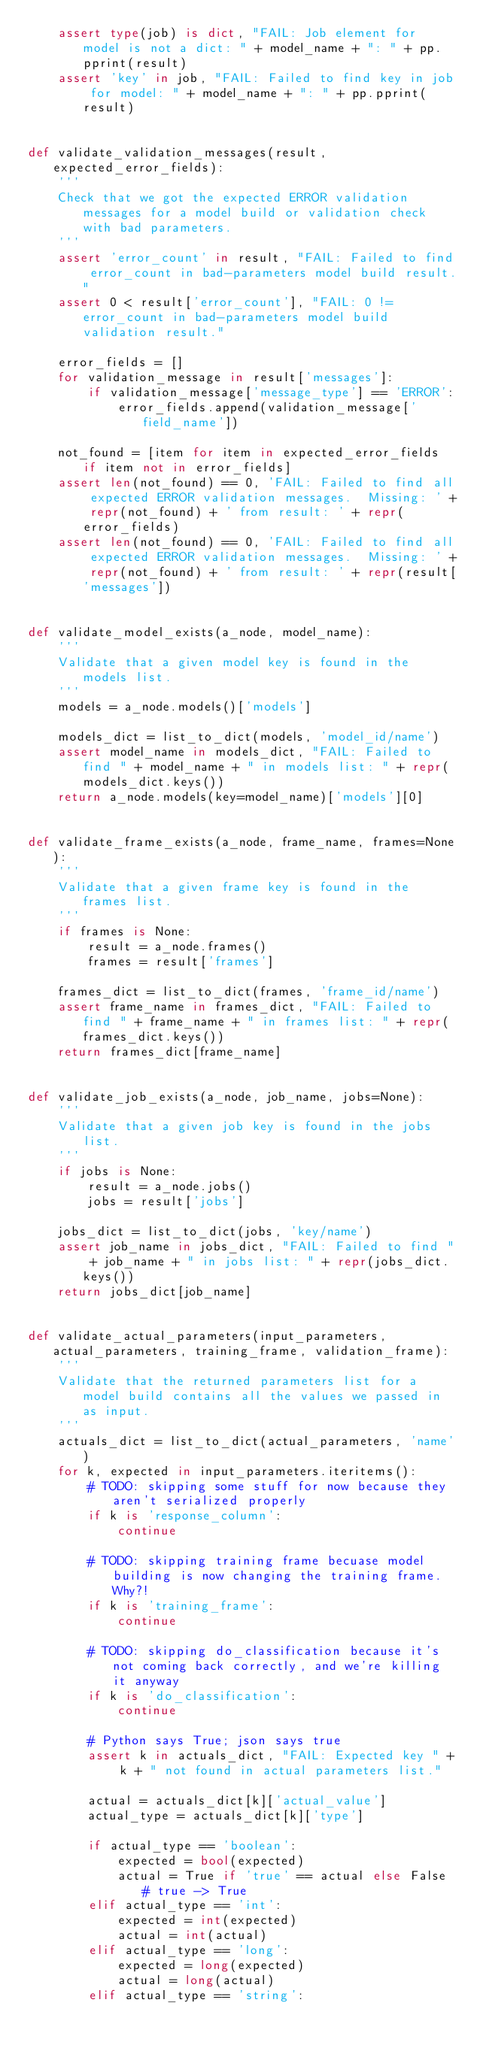<code> <loc_0><loc_0><loc_500><loc_500><_Python_>    assert type(job) is dict, "FAIL: Job element for model is not a dict: " + model_name + ": " + pp.pprint(result)
    assert 'key' in job, "FAIL: Failed to find key in job for model: " + model_name + ": " + pp.pprint(result)


def validate_validation_messages(result, expected_error_fields):
    '''
    Check that we got the expected ERROR validation messages for a model build or validation check with bad parameters.
    '''
    assert 'error_count' in result, "FAIL: Failed to find error_count in bad-parameters model build result."
    assert 0 < result['error_count'], "FAIL: 0 != error_count in bad-parameters model build validation result."

    error_fields = []
    for validation_message in result['messages']:
        if validation_message['message_type'] == 'ERROR':
            error_fields.append(validation_message['field_name'])

    not_found = [item for item in expected_error_fields if item not in error_fields]
    assert len(not_found) == 0, 'FAIL: Failed to find all expected ERROR validation messages.  Missing: ' + repr(not_found) + ' from result: ' + repr(error_fields)
    assert len(not_found) == 0, 'FAIL: Failed to find all expected ERROR validation messages.  Missing: ' + repr(not_found) + ' from result: ' + repr(result['messages'])


def validate_model_exists(a_node, model_name):
    '''
    Validate that a given model key is found in the models list.
    '''
    models = a_node.models()['models']

    models_dict = list_to_dict(models, 'model_id/name')
    assert model_name in models_dict, "FAIL: Failed to find " + model_name + " in models list: " + repr(models_dict.keys())
    return a_node.models(key=model_name)['models'][0]


def validate_frame_exists(a_node, frame_name, frames=None):
    '''
    Validate that a given frame key is found in the frames list.
    '''
    if frames is None:
        result = a_node.frames()
        frames = result['frames']

    frames_dict = list_to_dict(frames, 'frame_id/name')
    assert frame_name in frames_dict, "FAIL: Failed to find " + frame_name + " in frames list: " + repr(frames_dict.keys())
    return frames_dict[frame_name]


def validate_job_exists(a_node, job_name, jobs=None):
    '''
    Validate that a given job key is found in the jobs list.
    '''
    if jobs is None:
        result = a_node.jobs()
        jobs = result['jobs']

    jobs_dict = list_to_dict(jobs, 'key/name')
    assert job_name in jobs_dict, "FAIL: Failed to find " + job_name + " in jobs list: " + repr(jobs_dict.keys())
    return jobs_dict[job_name]


def validate_actual_parameters(input_parameters, actual_parameters, training_frame, validation_frame):
    '''
    Validate that the returned parameters list for a model build contains all the values we passed in as input.
    '''
    actuals_dict = list_to_dict(actual_parameters, 'name')
    for k, expected in input_parameters.iteritems():
        # TODO: skipping some stuff for now because they aren't serialized properly
        if k is 'response_column':
            continue

        # TODO: skipping training frame becuase model building is now changing the training frame.  Why?!
        if k is 'training_frame':
            continue

        # TODO: skipping do_classification because it's not coming back correctly, and we're killing it anyway
        if k is 'do_classification':
            continue

        # Python says True; json says true
        assert k in actuals_dict, "FAIL: Expected key " + k + " not found in actual parameters list."

        actual = actuals_dict[k]['actual_value']
        actual_type = actuals_dict[k]['type']

        if actual_type == 'boolean':
            expected = bool(expected)
            actual = True if 'true' == actual else False # true -> True
        elif actual_type == 'int':
            expected = int(expected)
            actual = int(actual)
        elif actual_type == 'long':
            expected = long(expected)
            actual = long(actual)
        elif actual_type == 'string':</code> 